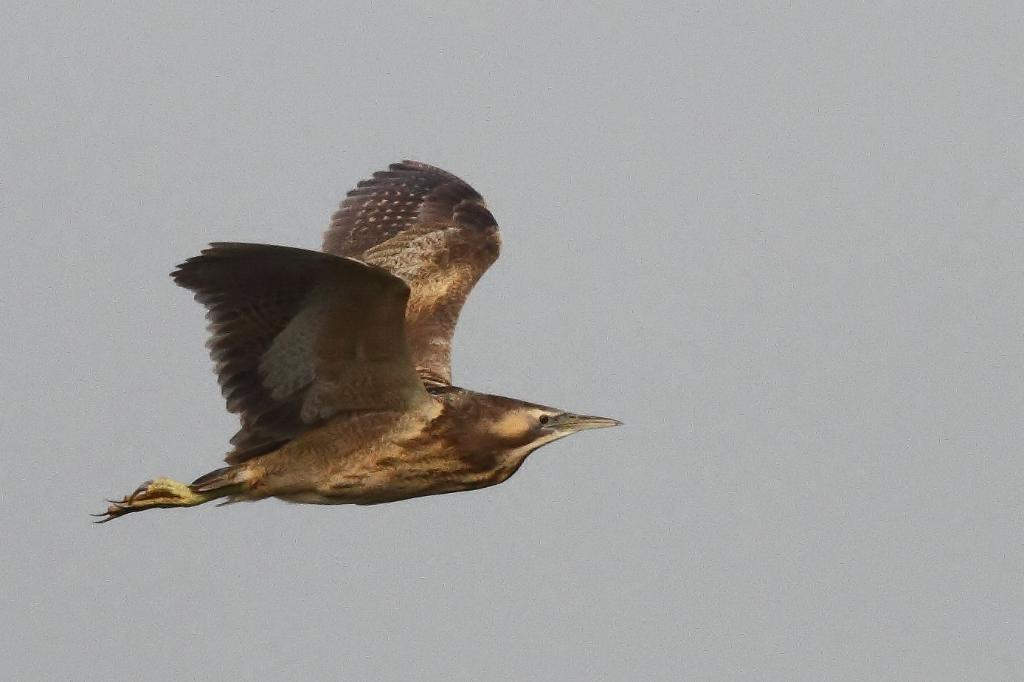What type of animal is present in the image? There is a bird in the image. What is the bird doing in the image? The bird is flying in the sky. In which direction is the bird flying? The bird is flying towards the right side. What type of advertisement can be seen on the bird's wings in the image? There is no advertisement present on the bird's wings in the image. What is the bird performing division on in the image? There is no division or mathematical operation being performed by the bird in the image. 